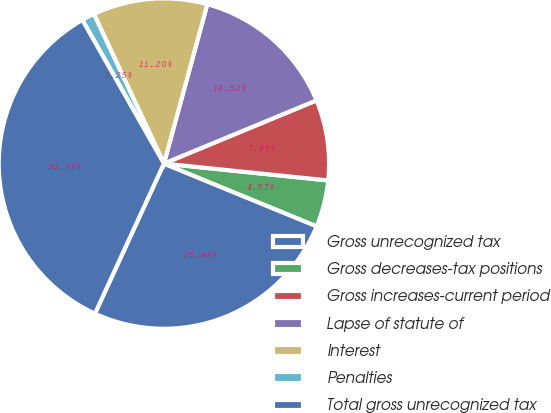Convert chart to OTSL. <chart><loc_0><loc_0><loc_500><loc_500><pie_chart><fcel>Gross unrecognized tax<fcel>Gross decreases-tax positions<fcel>Gross increases-current period<fcel>Lapse of statute of<fcel>Interest<fcel>Penalties<fcel>Total gross unrecognized tax<nl><fcel>25.66%<fcel>4.57%<fcel>7.88%<fcel>14.52%<fcel>11.2%<fcel>1.25%<fcel>34.92%<nl></chart> 